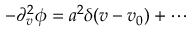Convert formula to latex. <formula><loc_0><loc_0><loc_500><loc_500>- \partial _ { v } ^ { 2 } \phi = a ^ { 2 } \delta ( v - v _ { 0 } ) + \cdots</formula> 